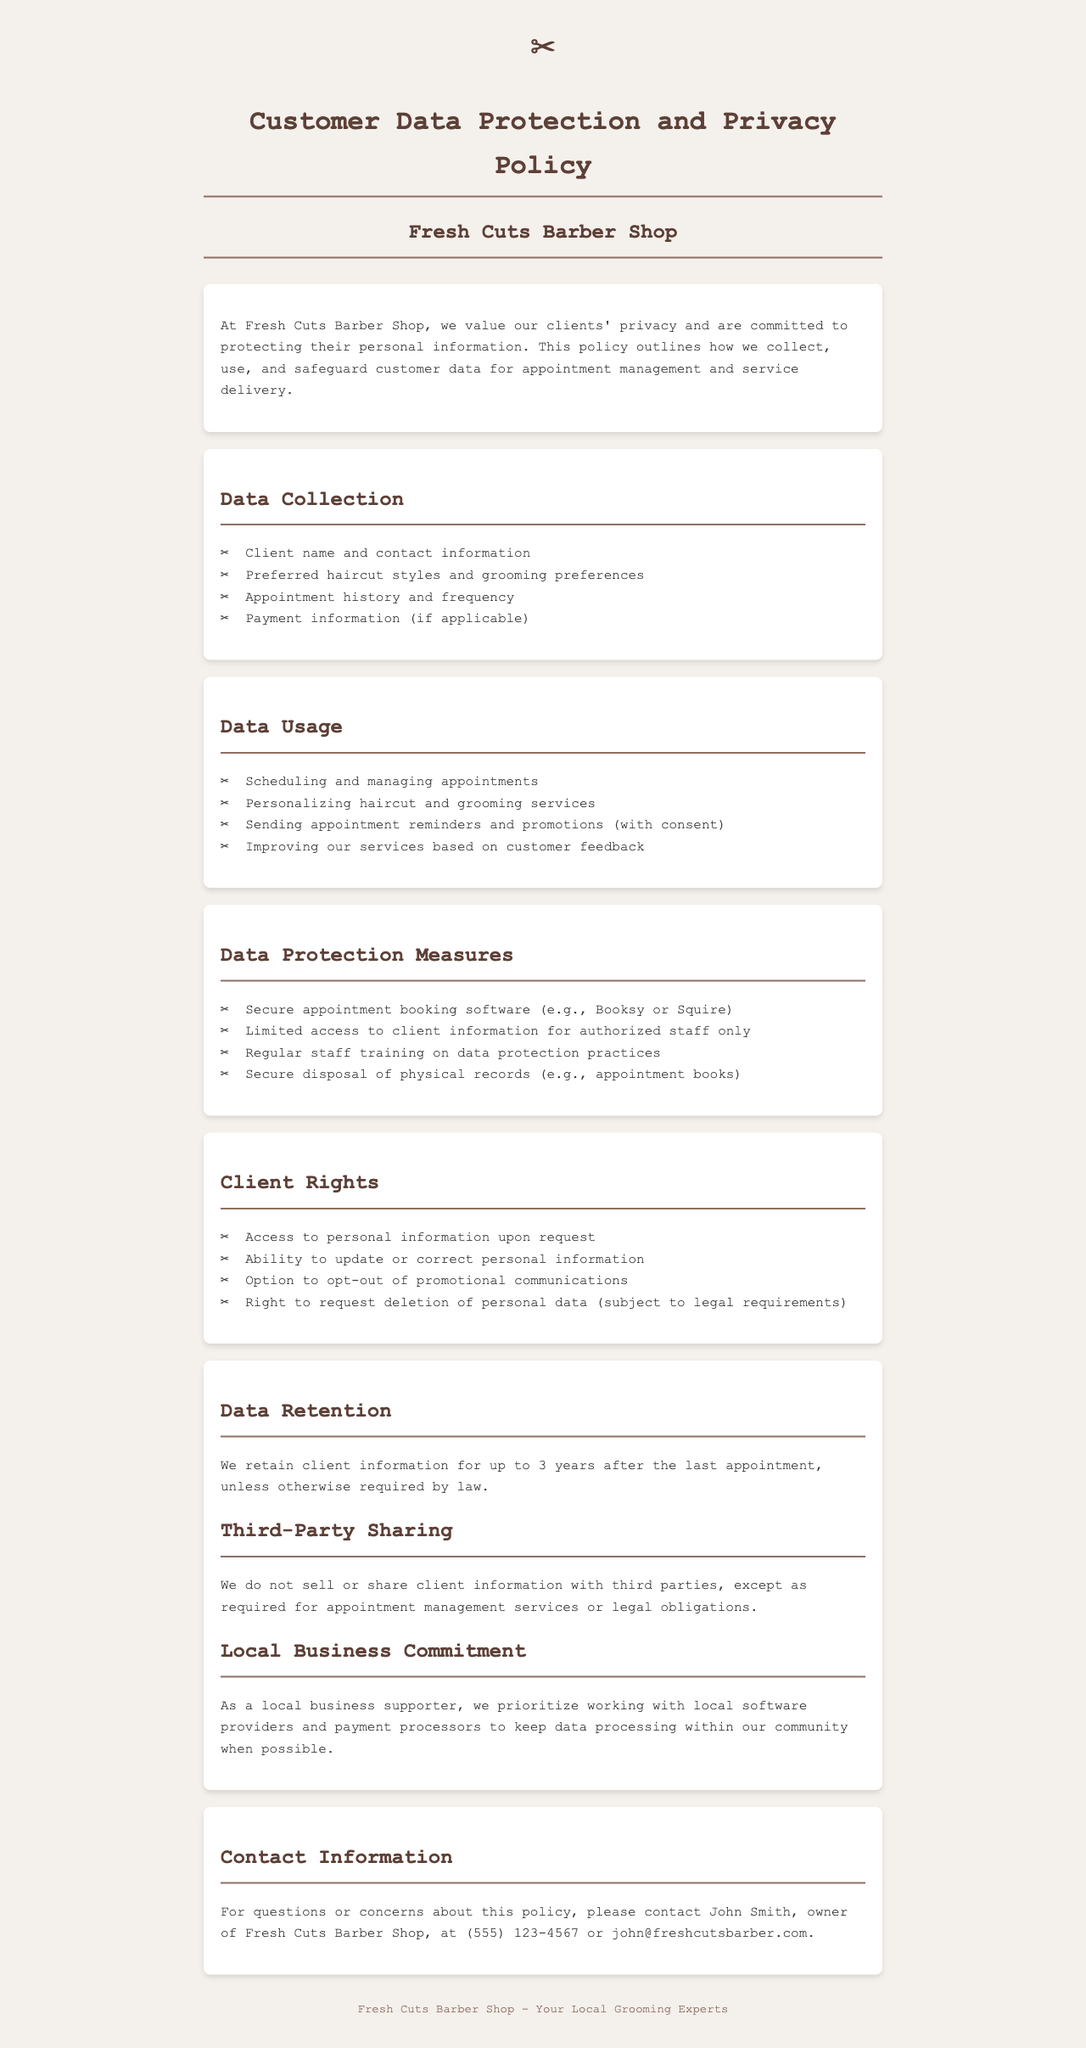What information does Fresh Cuts Barber Shop collect from clients? The section titled "Data Collection" lists the information collected, including client name, contact information, preferred haircut styles, appointment history, and payment information.
Answer: Client name and contact information, preferred haircut styles and grooming preferences, appointment history and frequency, payment information What is the maximum duration for retaining client information? The "Data Retention" section specifies how long client information is retained after the last appointment.
Answer: 3 years Who should clients contact for questions regarding the policy? The "Contact Information" section provides the name and contact details of the owner for any inquiries about the policy.
Answer: John Smith What rights do clients have concerning their personal information? The "Client Rights" section enumerates the rights that clients have regarding their information, including access, updates, and deletion requests.
Answer: Access to personal information, ability to update personal information, option to opt-out of promotional communications, right to request deletion What is one key data protection measure mentioned in the policy? The "Data Protection Measures" section highlights specific measures taken to protect client data, which demonstrates the commitment to safeguarding their information.
Answer: Secure appointment booking software What local commitment does the barber shop prioritize regarding data processing? The "Local Business Commitment" section discusses the shop’s philosophy regarding working with other local businesses for data processing purposes.
Answer: Working with local software providers and payment processors How are appointment reminders communicated to clients? The "Data Usage" section mentions that appointment reminders are sent with the consent of the clients.
Answer: Sending appointment reminders and promotions (with consent) Is client information shared with third parties? The "Third-Party Sharing" section clearly states the policy regarding sharing customer data with outside entities.
Answer: No, except as required for appointment management services or legal obligations 